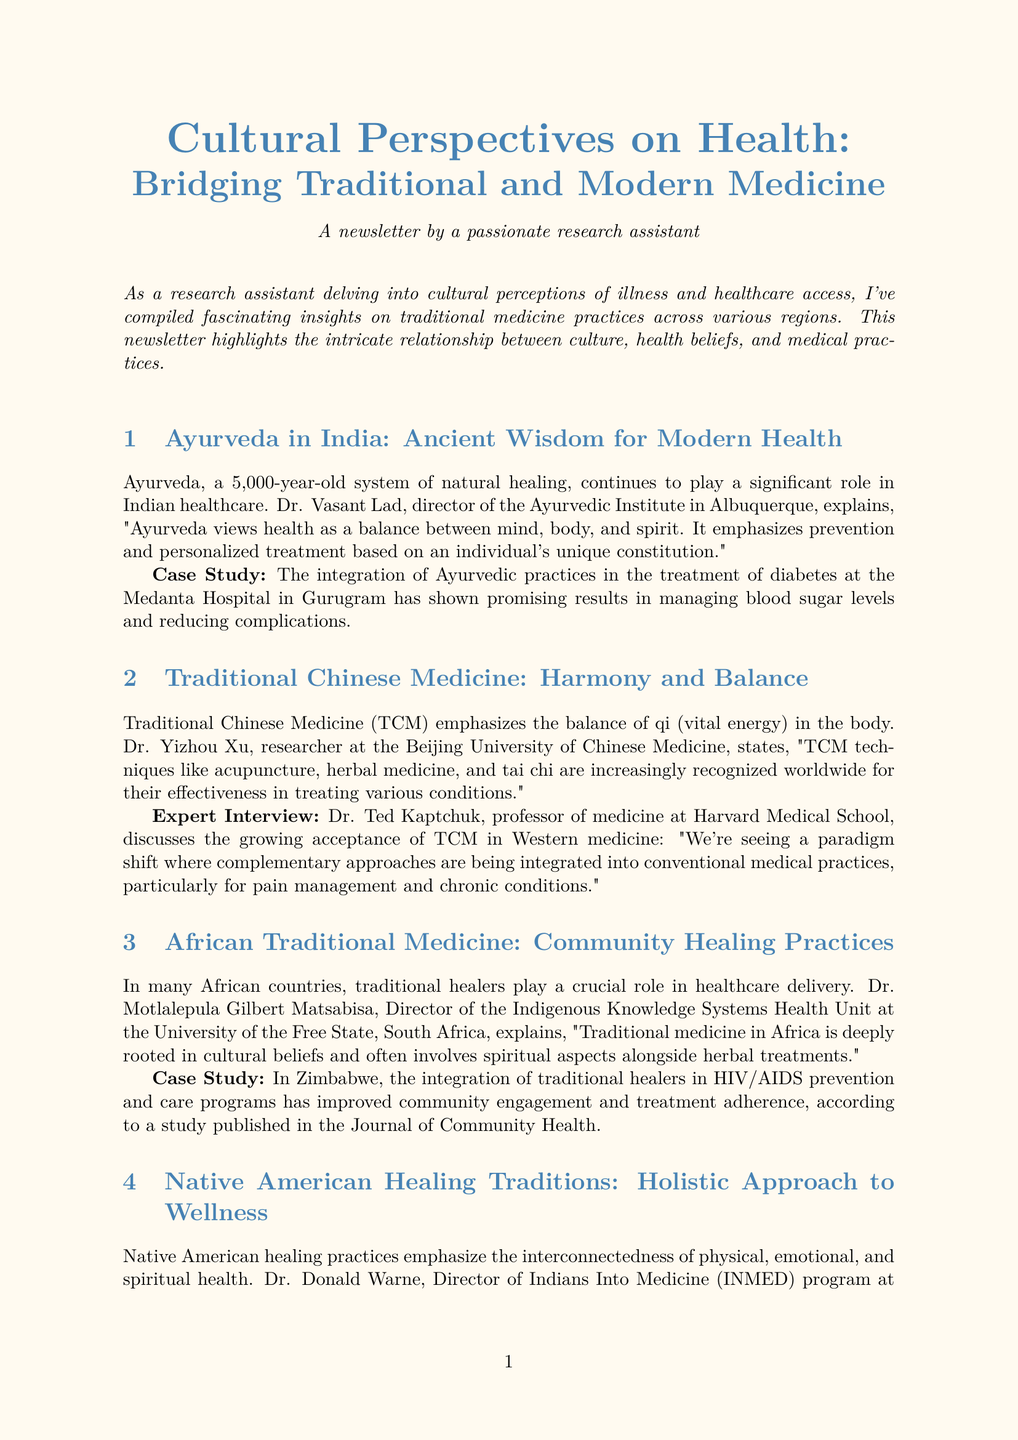What is the newsletter title? The title is mentioned at the beginning of the document and is "Cultural Perspectives on Health: Bridging Traditional and Modern Medicine."
Answer: Cultural Perspectives on Health: Bridging Traditional and Modern Medicine Who is the director of the Ayurvedic Institute? Dr. Vasant Lad is mentioned as the director of the Ayurvedic Institute in Albuquerque within the section on Ayurveda in India.
Answer: Dr. Vasant Lad What system of medicine is emphasized in Traditional Chinese Medicine? The document states that Traditional Chinese Medicine emphasizes the balance of qi (vital energy) in the body.
Answer: qi In which country is the University of the Free State located? The document mentions the University of the Free State is in South Africa in the context of African Traditional Medicine.
Answer: South Africa What is the main focus of Native American healing practices? The document describes Native American healing practices as emphasizing the interconnectedness of physical, emotional, and spiritual health.
Answer: interconnectedness What role does the World Health Organization play regarding traditional medicine? The document states that the World Health Organization promotes the integration of traditional medicine into national health systems.
Answer: WHO What evidence is provided for the effectiveness of traditional healers in Zimbabwe? The document references a study published in the Journal of Community Health regarding the integration of traditional healers in HIV/AIDS programs.
Answer: Journal of Community Health What is a significant outcome of integrating traditional medicine with modern healthcare in Malaysia? The document indicates that integrating traditional medicine with modern healthcare in Malaysia has improved patient outcomes and satisfaction.
Answer: improved patient outcomes and satisfaction Who discusses the importance of cultural competence in healthcare in the document? Henrietta Mann, Ph.D., discusses the importance of cultural competence in healthcare in the section on Native American healing traditions.
Answer: Henrietta Mann, Ph.D 